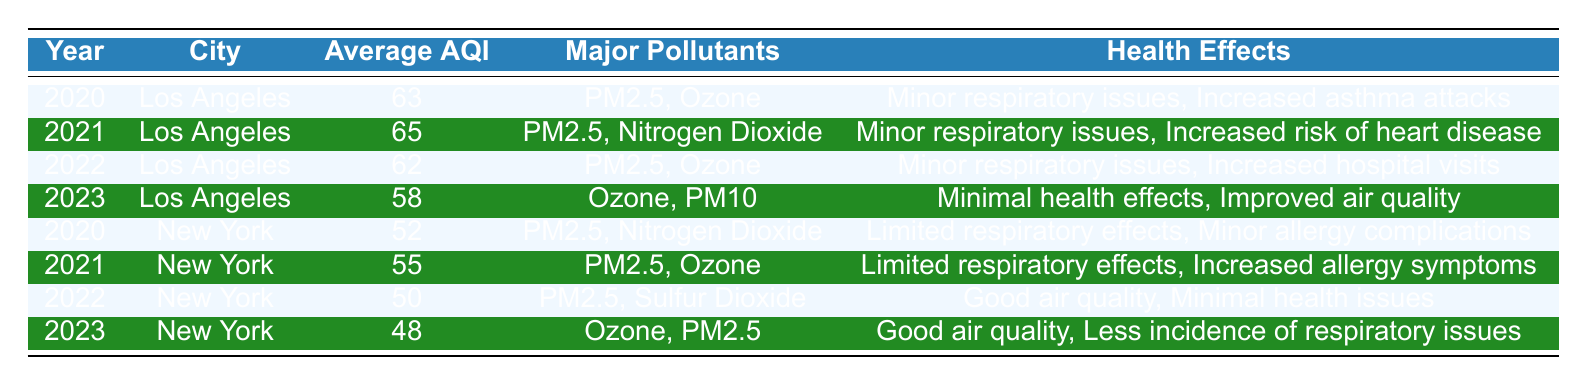What was the average AQI in Los Angeles in 2021? The table shows that the average AQI for Los Angeles in 2021 is listed as 65.
Answer: 65 Which city had the lowest average AQI over the four years? By comparing the average AQI values from each year for both cities: Los Angeles has 63, 65, 62, and 58, while New York has 52, 55, 50, and 48. The lowest average AQI is 48, recorded by New York in 2023.
Answer: New York Did air quality in New York improve from 2020 to 2023? In 2020, the average AQI in New York was 52, and it decreased to 48 by 2023. This indicates an improvement in air quality as the AQI values are lower.
Answer: Yes What are the major pollutants listed for Los Angeles in 2022? The table indicates that the major pollutants for Los Angeles in 2022 are PM2.5 and Ozone, as stated in the respective row.
Answer: PM2.5, Ozone Calculate the average AQI for Los Angeles over the four years provided. The average AQI for Los Angeles is calculated as (63 + 65 + 62 + 58) / 4. This results in a total of 248, and dividing by 4 gives an average AQI of 62.
Answer: 62 Was the health effect listed for Los Angeles in 2023 minimal? The health effects in Los Angeles for 2023 are stated as "Minimal health effects, Improved air quality," confirming the air quality did not pose significant risks.
Answer: Yes Which year's air quality in New York had the least health effects recorded? The year 2022 shows "Good air quality, Minimal health issues," which is the least concerning description of health effects for New York.
Answer: 2022 How many times did PM2.5 appear as a major pollutant in Los Angeles? PM2.5 appears in the major pollutants list for Los Angeles in 2020, 2021, and 2022, totaling three occurrences.
Answer: 3 What health issues are associated with the average AQI of 65 in Los Angeles? The 2021 entry for Los Angeles with an average AQI of 65 lists "Minor respiratory issues, Increased risk of heart disease" as associated health issues.
Answer: Minor respiratory issues, Increased risk of heart disease 